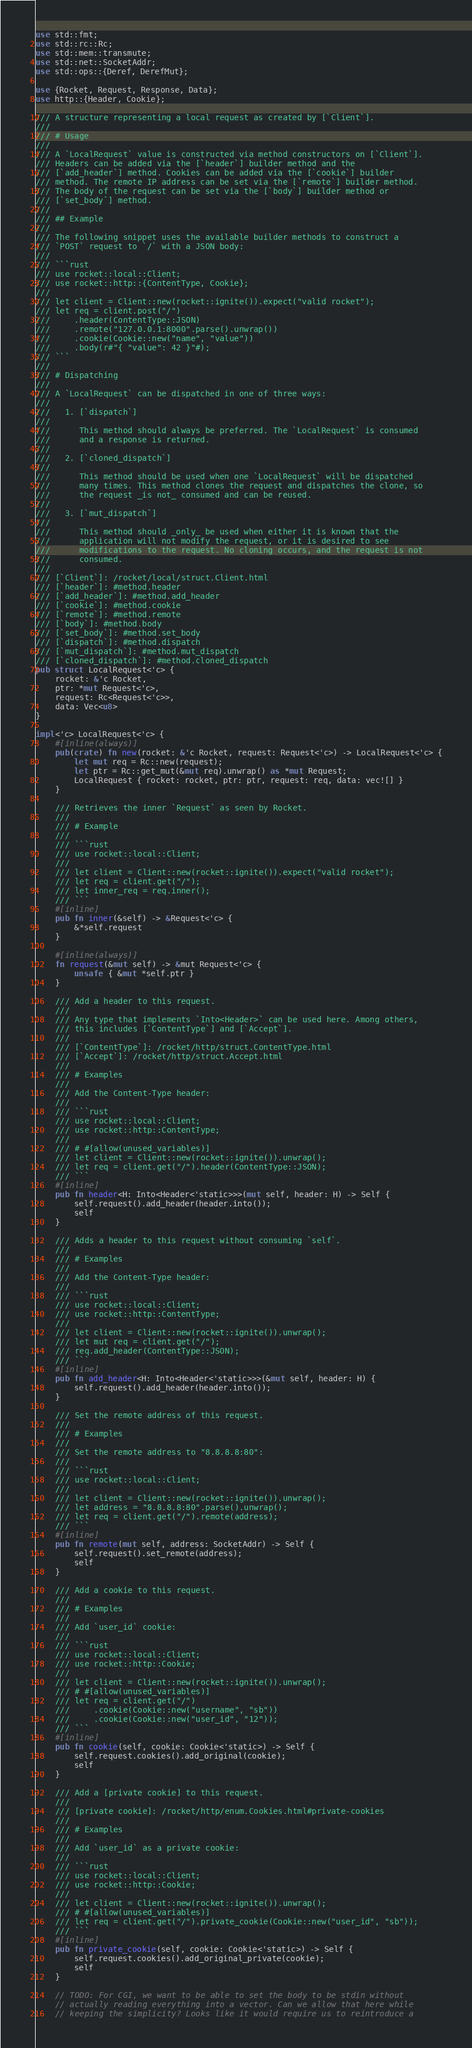<code> <loc_0><loc_0><loc_500><loc_500><_Rust_>use std::fmt;
use std::rc::Rc;
use std::mem::transmute;
use std::net::SocketAddr;
use std::ops::{Deref, DerefMut};

use {Rocket, Request, Response, Data};
use http::{Header, Cookie};

/// A structure representing a local request as created by [`Client`].
///
/// # Usage
///
/// A `LocalRequest` value is constructed via method constructors on [`Client`].
/// Headers can be added via the [`header`] builder method and the
/// [`add_header`] method. Cookies can be added via the [`cookie`] builder
/// method. The remote IP address can be set via the [`remote`] builder method.
/// The body of the request can be set via the [`body`] builder method or
/// [`set_body`] method.
///
/// ## Example
///
/// The following snippet uses the available builder methods to construct a
/// `POST` request to `/` with a JSON body:
///
/// ```rust
/// use rocket::local::Client;
/// use rocket::http::{ContentType, Cookie};
///
/// let client = Client::new(rocket::ignite()).expect("valid rocket");
/// let req = client.post("/")
///     .header(ContentType::JSON)
///     .remote("127.0.0.1:8000".parse().unwrap())
///     .cookie(Cookie::new("name", "value"))
///     .body(r#"{ "value": 42 }"#);
/// ```
///
/// # Dispatching
///
/// A `LocalRequest` can be dispatched in one of three ways:
///
///   1. [`dispatch`]
///
///      This method should always be preferred. The `LocalRequest` is consumed
///      and a response is returned.
///
///   2. [`cloned_dispatch`]
///
///      This method should be used when one `LocalRequest` will be dispatched
///      many times. This method clones the request and dispatches the clone, so
///      the request _is not_ consumed and can be reused.
///
///   3. [`mut_dispatch`]
///
///      This method should _only_ be used when either it is known that the
///      application will not modify the request, or it is desired to see
///      modifications to the request. No cloning occurs, and the request is not
///      consumed.
///
/// [`Client`]: /rocket/local/struct.Client.html
/// [`header`]: #method.header
/// [`add_header`]: #method.add_header
/// [`cookie`]: #method.cookie
/// [`remote`]: #method.remote
/// [`body`]: #method.body
/// [`set_body`]: #method.set_body
/// [`dispatch`]: #method.dispatch
/// [`mut_dispatch`]: #method.mut_dispatch
/// [`cloned_dispatch`]: #method.cloned_dispatch
pub struct LocalRequest<'c> {
    rocket: &'c Rocket,
    ptr: *mut Request<'c>,
    request: Rc<Request<'c>>,
    data: Vec<u8>
}

impl<'c> LocalRequest<'c> {
    #[inline(always)]
    pub(crate) fn new(rocket: &'c Rocket, request: Request<'c>) -> LocalRequest<'c> {
        let mut req = Rc::new(request);
        let ptr = Rc::get_mut(&mut req).unwrap() as *mut Request;
        LocalRequest { rocket: rocket, ptr: ptr, request: req, data: vec![] }
    }

    /// Retrieves the inner `Request` as seen by Rocket.
    ///
    /// # Example
    ///
    /// ```rust
    /// use rocket::local::Client;
    ///
    /// let client = Client::new(rocket::ignite()).expect("valid rocket");
    /// let req = client.get("/");
    /// let inner_req = req.inner();
    /// ```
    #[inline]
    pub fn inner(&self) -> &Request<'c> {
        &*self.request
    }

    #[inline(always)]
    fn request(&mut self) -> &mut Request<'c> {
        unsafe { &mut *self.ptr }
    }

    /// Add a header to this request.
    ///
    /// Any type that implements `Into<Header>` can be used here. Among others,
    /// this includes [`ContentType`] and [`Accept`].
    ///
    /// [`ContentType`]: /rocket/http/struct.ContentType.html
    /// [`Accept`]: /rocket/http/struct.Accept.html
    ///
    /// # Examples
    ///
    /// Add the Content-Type header:
    ///
    /// ```rust
    /// use rocket::local::Client;
    /// use rocket::http::ContentType;
    ///
    /// # #[allow(unused_variables)]
    /// let client = Client::new(rocket::ignite()).unwrap();
    /// let req = client.get("/").header(ContentType::JSON);
    /// ```
    #[inline]
    pub fn header<H: Into<Header<'static>>>(mut self, header: H) -> Self {
        self.request().add_header(header.into());
        self
    }

    /// Adds a header to this request without consuming `self`.
    ///
    /// # Examples
    ///
    /// Add the Content-Type header:
    ///
    /// ```rust
    /// use rocket::local::Client;
    /// use rocket::http::ContentType;
    ///
    /// let client = Client::new(rocket::ignite()).unwrap();
    /// let mut req = client.get("/");
    /// req.add_header(ContentType::JSON);
    /// ```
    #[inline]
    pub fn add_header<H: Into<Header<'static>>>(&mut self, header: H) {
        self.request().add_header(header.into());
    }

    /// Set the remote address of this request.
    ///
    /// # Examples
    ///
    /// Set the remote address to "8.8.8.8:80":
    ///
    /// ```rust
    /// use rocket::local::Client;
    ///
    /// let client = Client::new(rocket::ignite()).unwrap();
    /// let address = "8.8.8.8:80".parse().unwrap();
    /// let req = client.get("/").remote(address);
    /// ```
    #[inline]
    pub fn remote(mut self, address: SocketAddr) -> Self {
        self.request().set_remote(address);
        self
    }

    /// Add a cookie to this request.
    ///
    /// # Examples
    ///
    /// Add `user_id` cookie:
    ///
    /// ```rust
    /// use rocket::local::Client;
    /// use rocket::http::Cookie;
    ///
    /// let client = Client::new(rocket::ignite()).unwrap();
    /// # #[allow(unused_variables)]
    /// let req = client.get("/")
    ///     .cookie(Cookie::new("username", "sb"))
    ///     .cookie(Cookie::new("user_id", "12"));
    /// ```
    #[inline]
    pub fn cookie(self, cookie: Cookie<'static>) -> Self {
        self.request.cookies().add_original(cookie);
        self
    }

    /// Add a [private cookie] to this request.
    ///
    /// [private cookie]: /rocket/http/enum.Cookies.html#private-cookies
    ///
    /// # Examples
    ///
    /// Add `user_id` as a private cookie:
    ///
    /// ```rust
    /// use rocket::local::Client;
    /// use rocket::http::Cookie;
    ///
    /// let client = Client::new(rocket::ignite()).unwrap();
    /// # #[allow(unused_variables)]
    /// let req = client.get("/").private_cookie(Cookie::new("user_id", "sb"));
    /// ```
    #[inline]
    pub fn private_cookie(self, cookie: Cookie<'static>) -> Self {
        self.request.cookies().add_original_private(cookie);
        self
    }

    // TODO: For CGI, we want to be able to set the body to be stdin without
    // actually reading everything into a vector. Can we allow that here while
    // keeping the simplicity? Looks like it would require us to reintroduce a</code> 